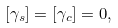<formula> <loc_0><loc_0><loc_500><loc_500>[ \gamma _ { s } ] = [ \gamma _ { c } ] = 0 ,</formula> 